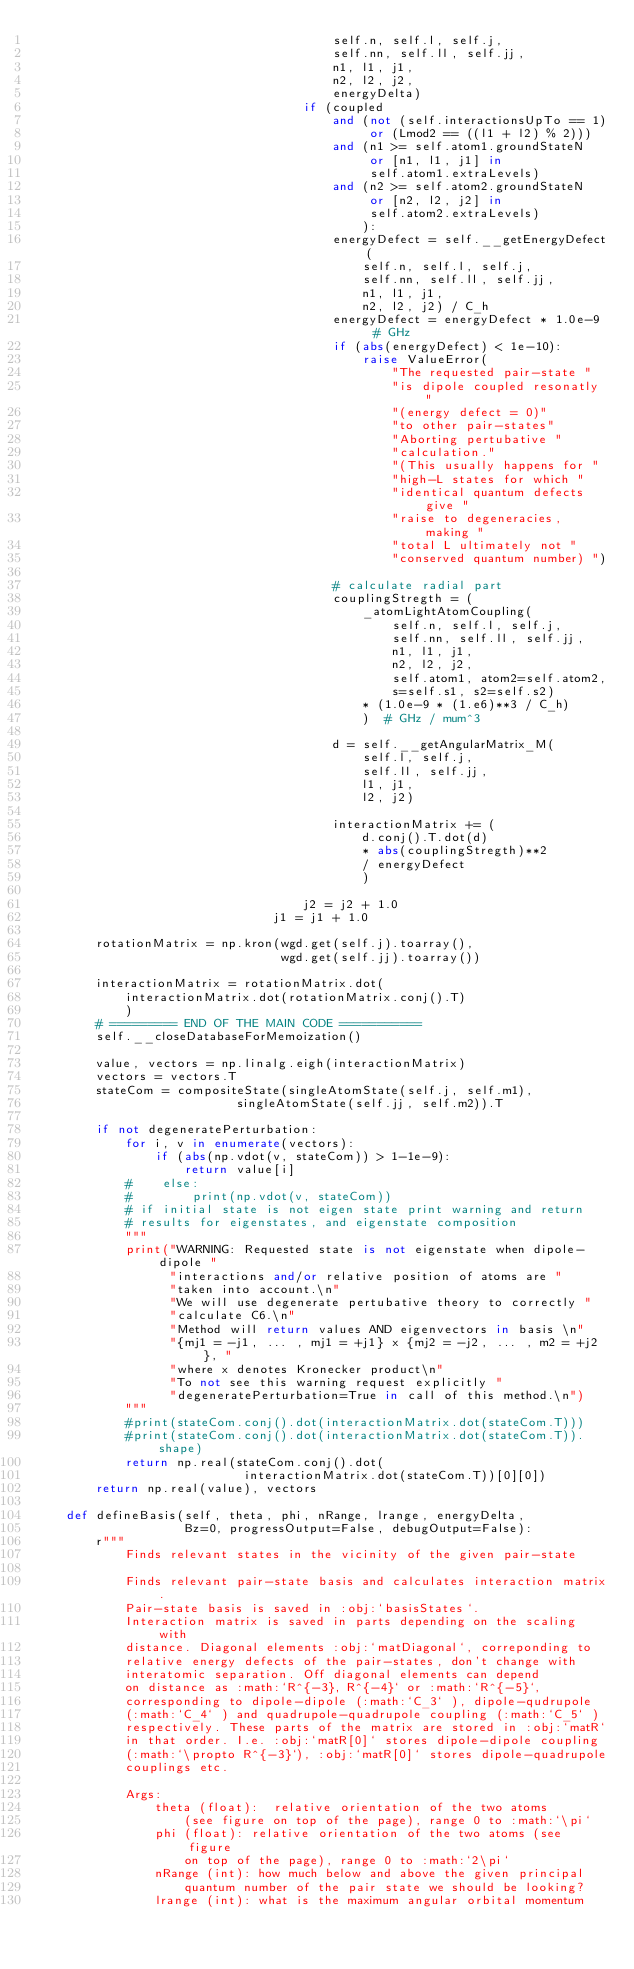<code> <loc_0><loc_0><loc_500><loc_500><_Python_>                                        self.n, self.l, self.j,
                                        self.nn, self.ll, self.jj,
                                        n1, l1, j1,
                                        n2, l2, j2,
                                        energyDelta)
                                    if (coupled
                                        and (not (self.interactionsUpTo == 1)
                                             or (Lmod2 == ((l1 + l2) % 2)))
                                        and (n1 >= self.atom1.groundStateN
                                             or [n1, l1, j1] in
                                             self.atom1.extraLevels)
                                        and (n2 >= self.atom2.groundStateN
                                             or [n2, l2, j2] in
                                             self.atom2.extraLevels)
                                            ):
                                        energyDefect = self.__getEnergyDefect(
                                            self.n, self.l, self.j,
                                            self.nn, self.ll, self.jj,
                                            n1, l1, j1,
                                            n2, l2, j2) / C_h
                                        energyDefect = energyDefect * 1.0e-9  # GHz
                                        if (abs(energyDefect) < 1e-10):
                                            raise ValueError(
                                                "The requested pair-state "
                                                "is dipole coupled resonatly "
                                                "(energy defect = 0)"
                                                "to other pair-states"
                                                "Aborting pertubative "
                                                "calculation."
                                                "(This usually happens for "
                                                "high-L states for which "
                                                "identical quantum defects give "
                                                "raise to degeneracies, making "
                                                "total L ultimately not "
                                                "conserved quantum number) ")

                                        # calculate radial part
                                        couplingStregth = (
                                            _atomLightAtomCoupling(
                                                self.n, self.l, self.j,
                                                self.nn, self.ll, self.jj,
                                                n1, l1, j1,
                                                n2, l2, j2,
                                                self.atom1, atom2=self.atom2,
                                                s=self.s1, s2=self.s2)
                                            * (1.0e-9 * (1.e6)**3 / C_h)
                                            )  # GHz / mum^3

                                        d = self.__getAngularMatrix_M(
                                            self.l, self.j,
                                            self.ll, self.jj,
                                            l1, j1,
                                            l2, j2)

                                        interactionMatrix += (
                                            d.conj().T.dot(d)
                                            * abs(couplingStregth)**2
                                            / energyDefect
                                            )

                                    j2 = j2 + 1.0
                                j1 = j1 + 1.0

        rotationMatrix = np.kron(wgd.get(self.j).toarray(),
                                 wgd.get(self.jj).toarray())

        interactionMatrix = rotationMatrix.dot(
            interactionMatrix.dot(rotationMatrix.conj().T)
            )
        # ========= END OF THE MAIN CODE ===========
        self.__closeDatabaseForMemoization()

        value, vectors = np.linalg.eigh(interactionMatrix)
        vectors = vectors.T
        stateCom = compositeState(singleAtomState(self.j, self.m1),
                           singleAtomState(self.jj, self.m2)).T

        if not degeneratePerturbation:
            for i, v in enumerate(vectors):
                if (abs(np.vdot(v, stateCom)) > 1-1e-9):
                    return value[i]
            #    else:
            #        print(np.vdot(v, stateCom))
            # if initial state is not eigen state print warning and return
            # results for eigenstates, and eigenstate composition
            """
            print("WARNING: Requested state is not eigenstate when dipole-dipole "
                  "interactions and/or relative position of atoms are "
                  "taken into account.\n"
                  "We will use degenerate pertubative theory to correctly "
                  "calculate C6.\n"
                  "Method will return values AND eigenvectors in basis \n"
                  "{mj1 = -j1, ... , mj1 = +j1} x {mj2 = -j2, ... , m2 = +j2}, "
                  "where x denotes Kronecker product\n"
                  "To not see this warning request explicitly "
                  "degeneratePerturbation=True in call of this method.\n")
            """
            #print(stateCom.conj().dot(interactionMatrix.dot(stateCom.T)))
            #print(stateCom.conj().dot(interactionMatrix.dot(stateCom.T)).shape)
            return np.real(stateCom.conj().dot(
                            interactionMatrix.dot(stateCom.T))[0][0])
        return np.real(value), vectors

    def defineBasis(self, theta, phi, nRange, lrange, energyDelta,
                    Bz=0, progressOutput=False, debugOutput=False):
        r"""
            Finds relevant states in the vicinity of the given pair-state

            Finds relevant pair-state basis and calculates interaction matrix.
            Pair-state basis is saved in :obj:`basisStates`.
            Interaction matrix is saved in parts depending on the scaling with
            distance. Diagonal elements :obj:`matDiagonal`, correponding to
            relative energy defects of the pair-states, don't change with
            interatomic separation. Off diagonal elements can depend
            on distance as :math:`R^{-3}, R^{-4}` or :math:`R^{-5}`,
            corresponding to dipole-dipole (:math:`C_3` ), dipole-qudrupole
            (:math:`C_4` ) and quadrupole-quadrupole coupling (:math:`C_5` )
            respectively. These parts of the matrix are stored in :obj:`matR`
            in that order. I.e. :obj:`matR[0]` stores dipole-dipole coupling
            (:math:`\propto R^{-3}`), :obj:`matR[0]` stores dipole-quadrupole
            couplings etc.

            Args:
                theta (float):  relative orientation of the two atoms
                    (see figure on top of the page), range 0 to :math:`\pi`
                phi (float): relative orientation of the two atoms (see figure
                    on top of the page), range 0 to :math:`2\pi`
                nRange (int): how much below and above the given principal
                    quantum number of the pair state we should be looking?
                lrange (int): what is the maximum angular orbital momentum</code> 